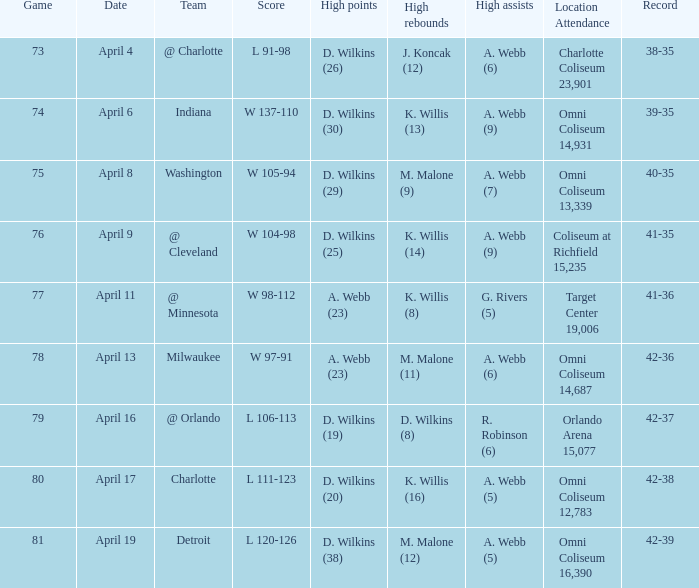Who had the high assists when the opponent was Indiana? A. Webb (9). 